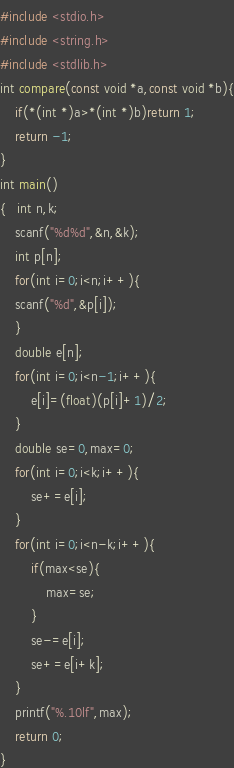<code> <loc_0><loc_0><loc_500><loc_500><_C_>
#include <stdio.h>
#include <string.h>
#include <stdlib.h>
int compare(const void *a,const void *b){
    if(*(int *)a>*(int *)b)return 1;
    return -1;
}
int main()
{   int n,k;
    scanf("%d%d",&n,&k);
    int p[n];
    for(int i=0;i<n;i++){
    scanf("%d",&p[i]);
    }
    double e[n];
    for(int i=0;i<n-1;i++){
        e[i]=(float)(p[i]+1)/2;
    }
    double se=0,max=0;
    for(int i=0;i<k;i++){
        se+=e[i];    
    }
    for(int i=0;i<n-k;i++){
        if(max<se){
            max=se;
        }
        se-=e[i];
        se+=e[i+k];
    }
    printf("%.10lf",max);
    return 0;
}
</code> 